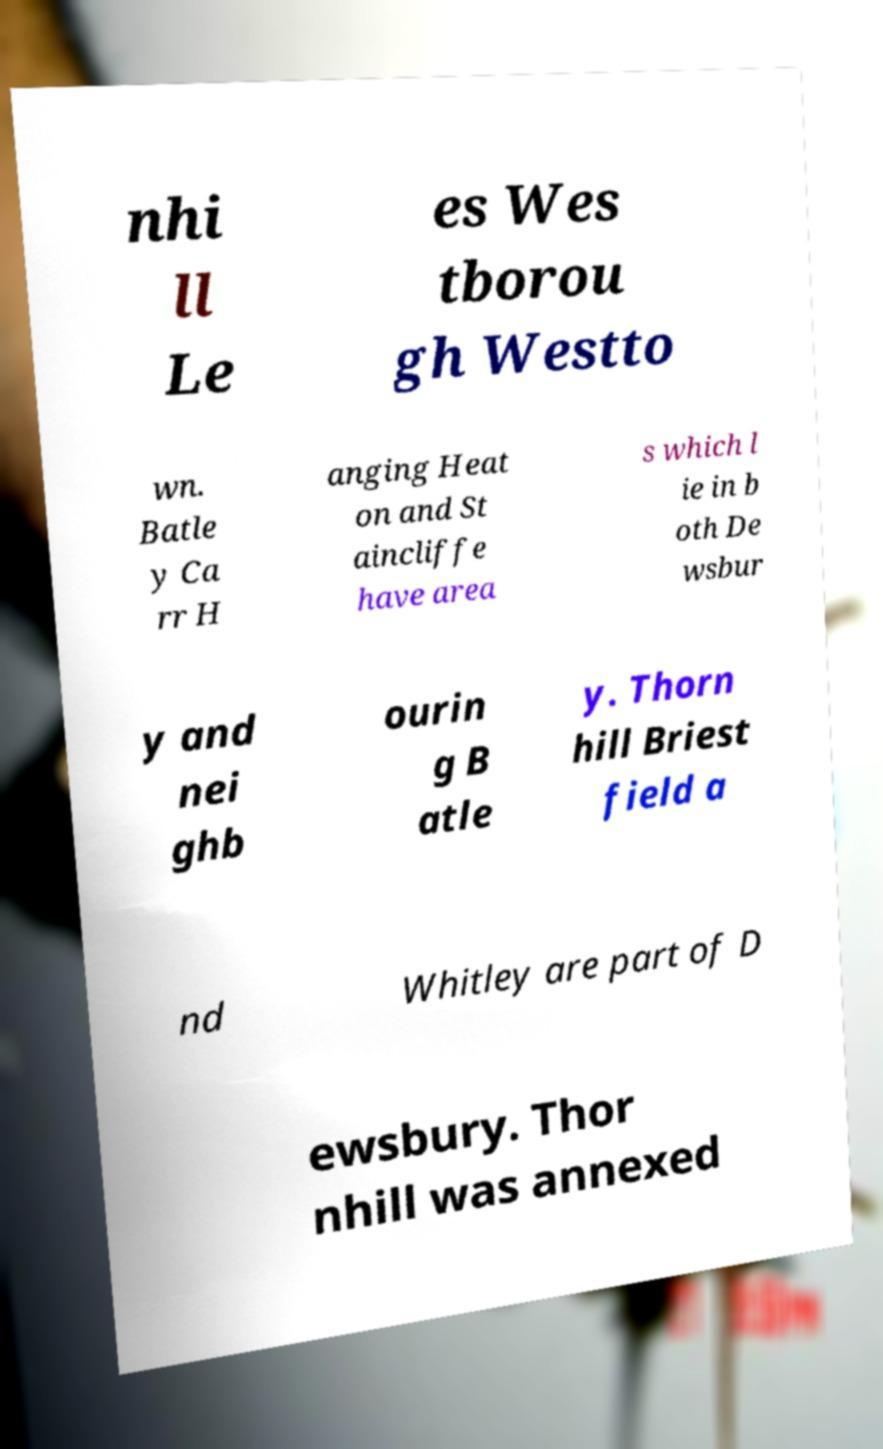I need the written content from this picture converted into text. Can you do that? nhi ll Le es Wes tborou gh Westto wn. Batle y Ca rr H anging Heat on and St aincliffe have area s which l ie in b oth De wsbur y and nei ghb ourin g B atle y. Thorn hill Briest field a nd Whitley are part of D ewsbury. Thor nhill was annexed 